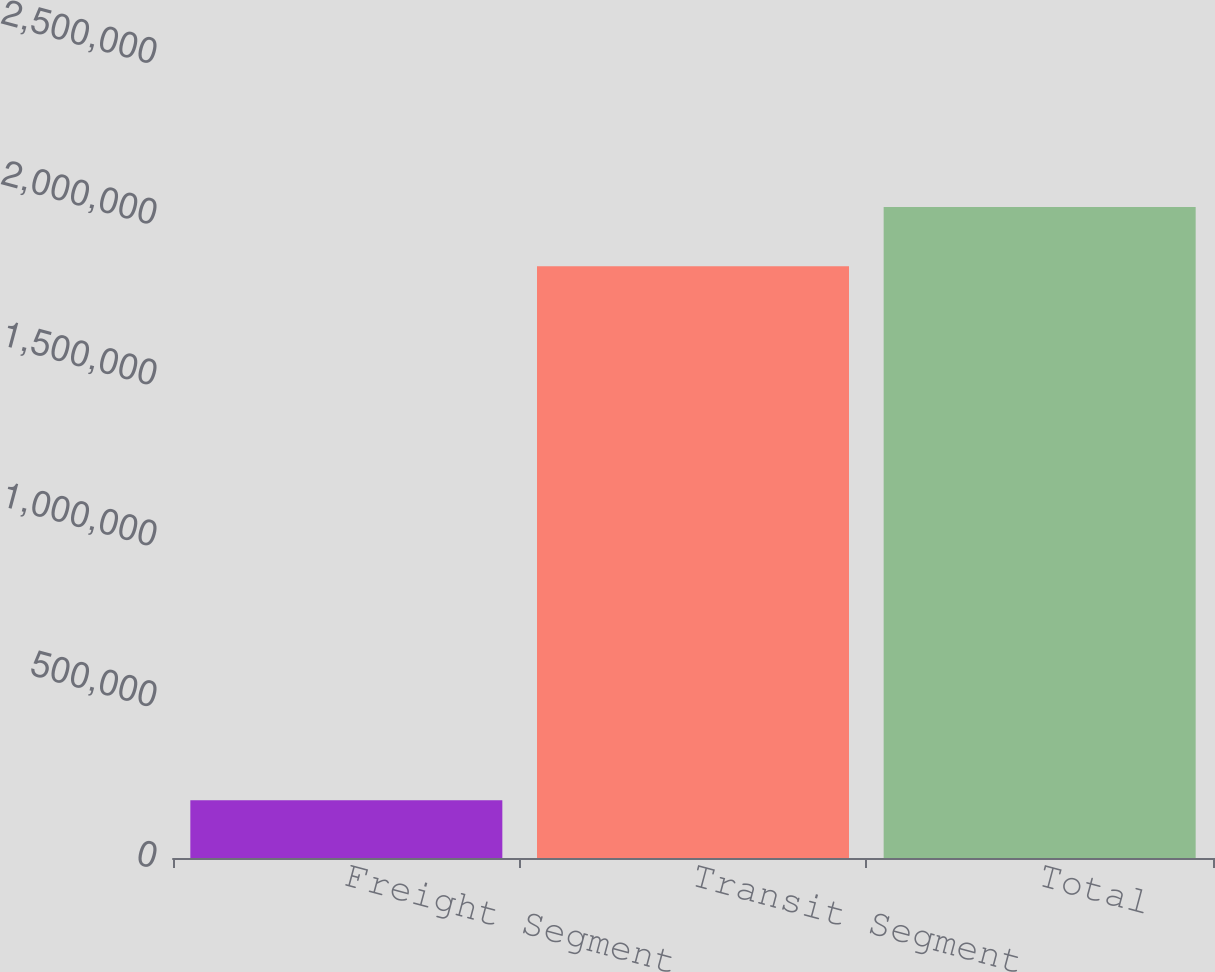Convert chart. <chart><loc_0><loc_0><loc_500><loc_500><bar_chart><fcel>Freight Segment<fcel>Transit Segment<fcel>Total<nl><fcel>179771<fcel>1.84004e+06<fcel>2.02405e+06<nl></chart> 